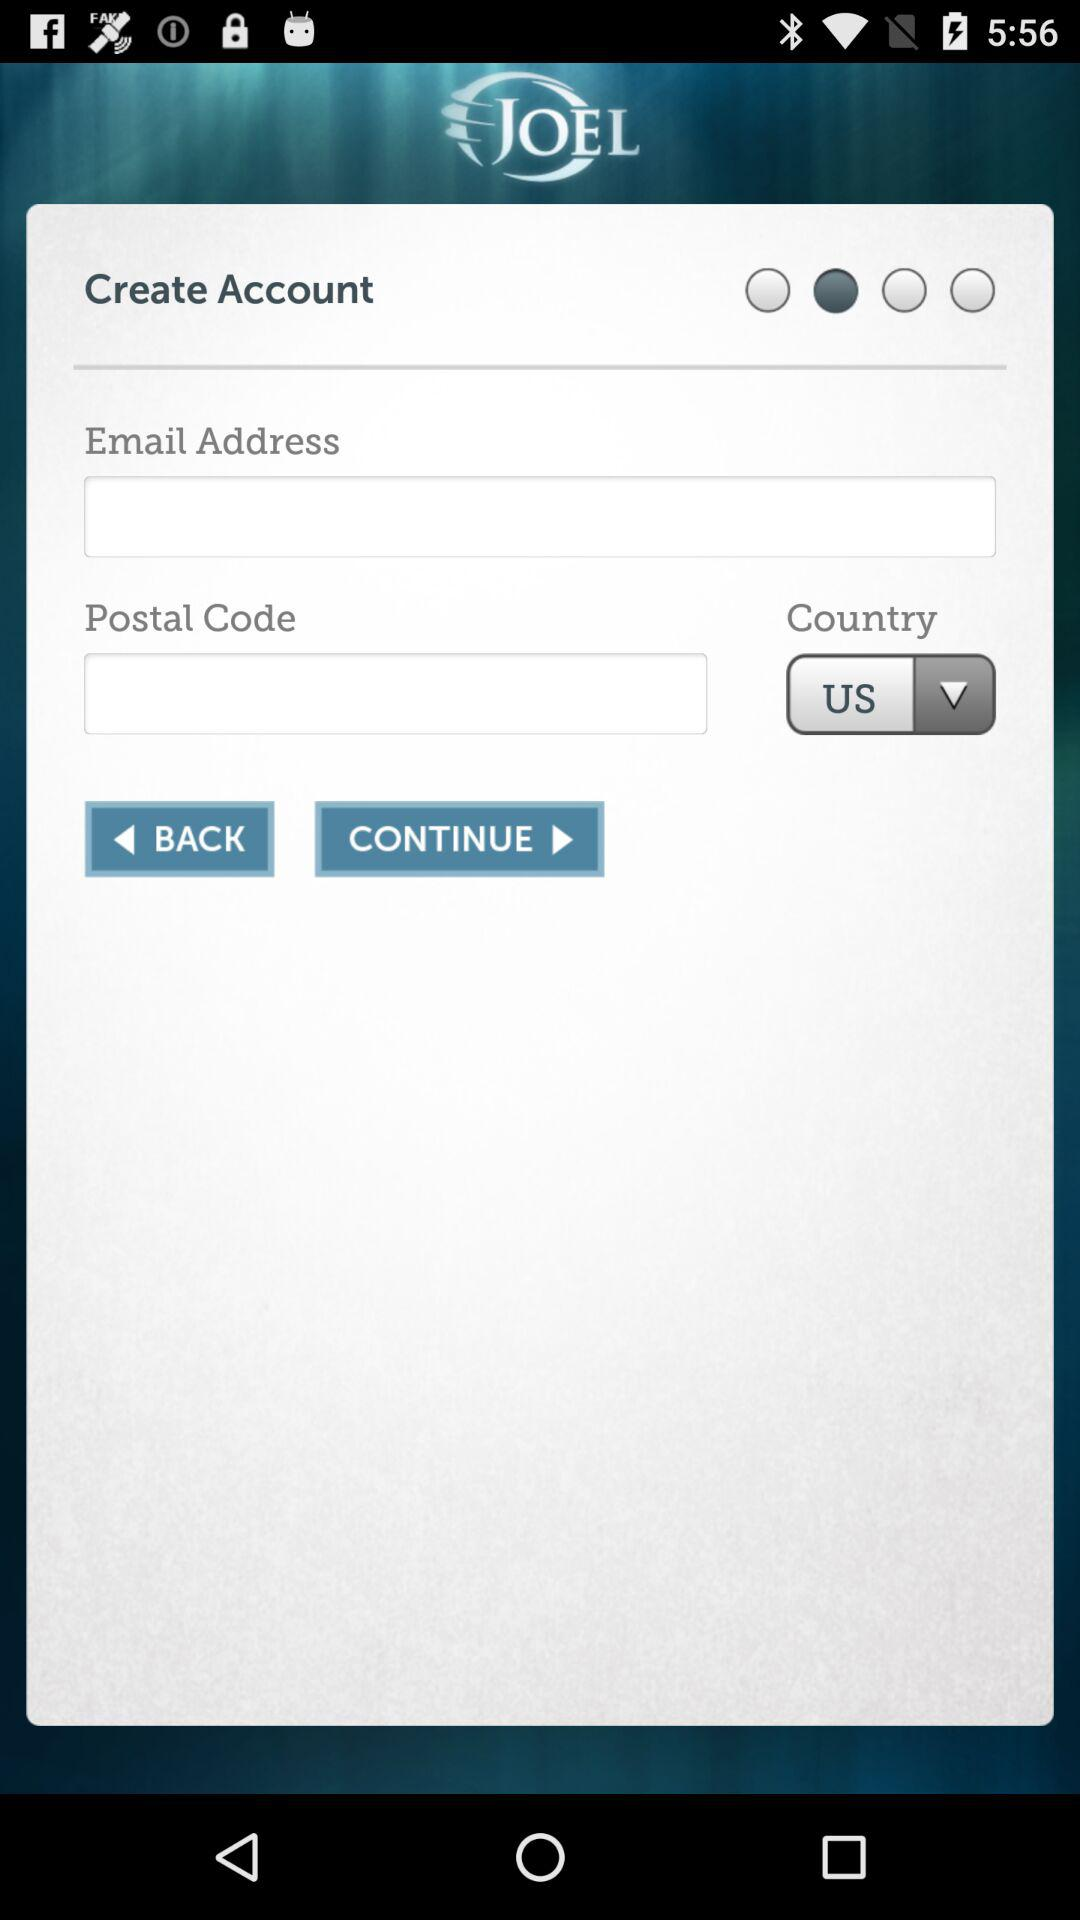What is the name of the application? The name of the application is "JOEL". 